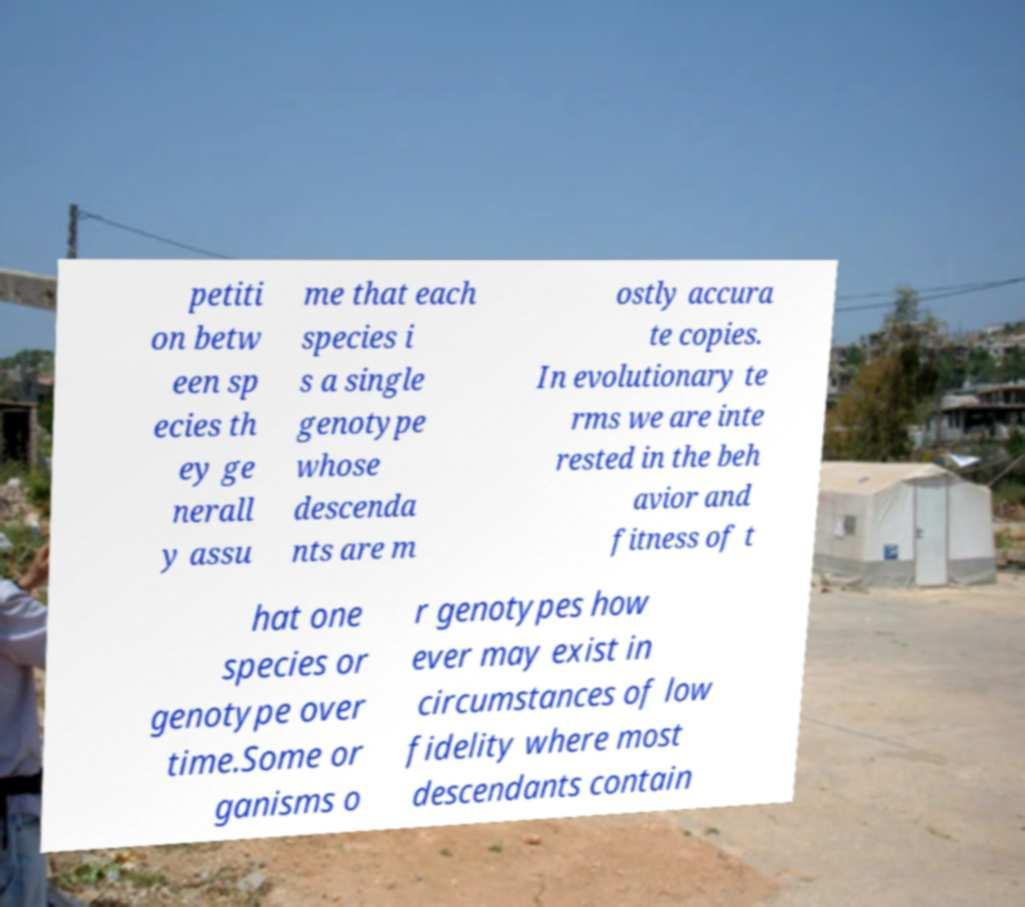Could you extract and type out the text from this image? petiti on betw een sp ecies th ey ge nerall y assu me that each species i s a single genotype whose descenda nts are m ostly accura te copies. In evolutionary te rms we are inte rested in the beh avior and fitness of t hat one species or genotype over time.Some or ganisms o r genotypes how ever may exist in circumstances of low fidelity where most descendants contain 